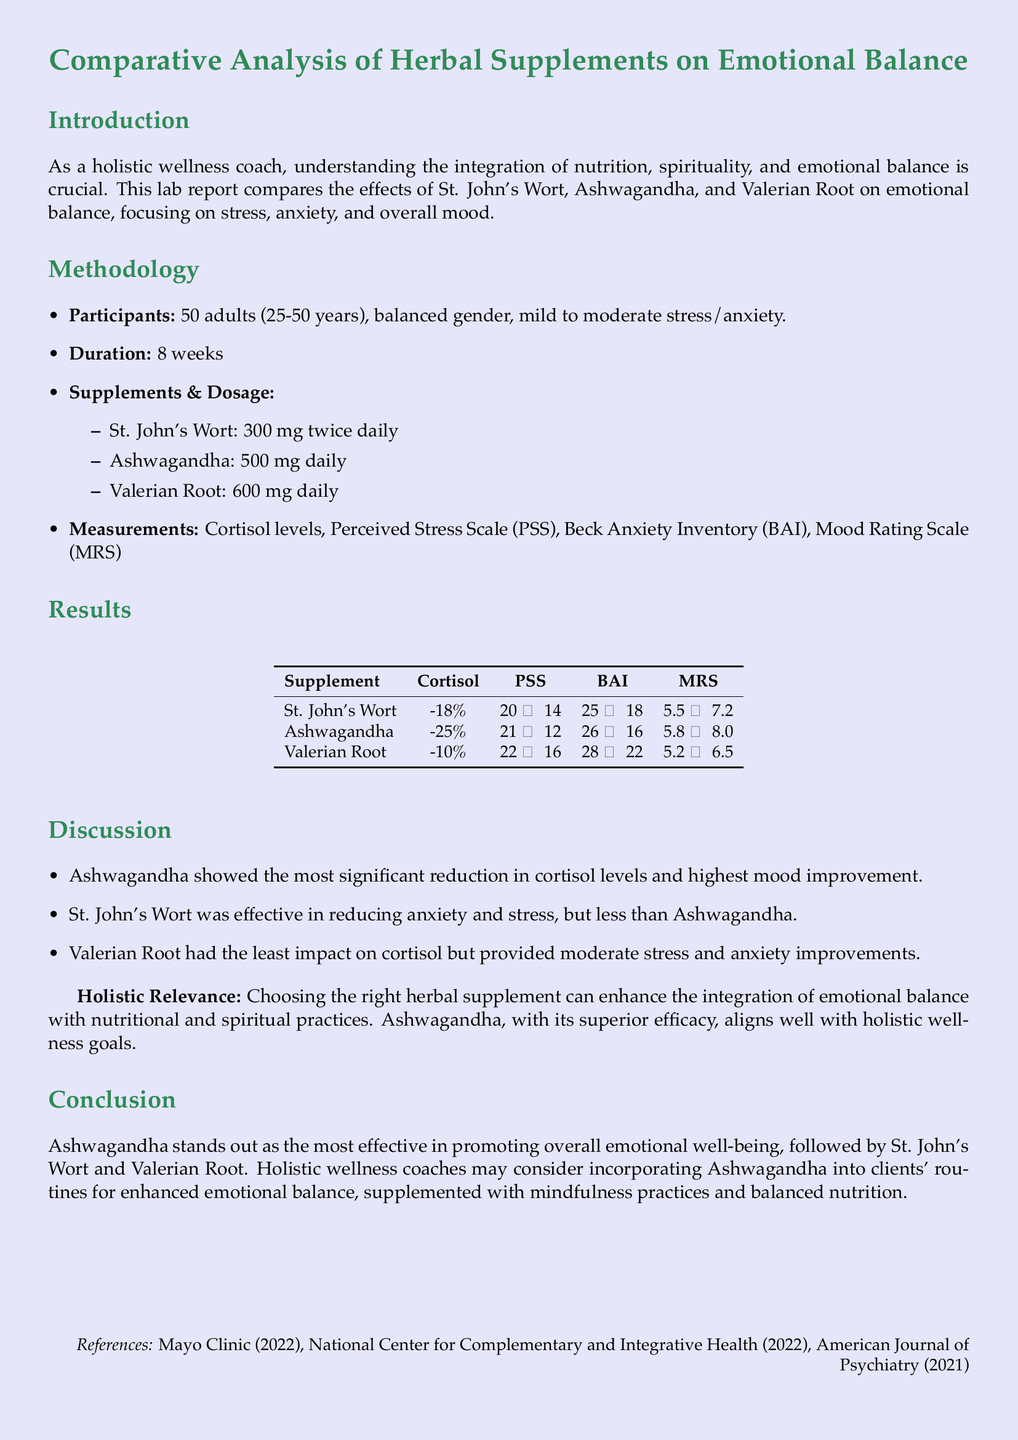What are the three herbal supplements analyzed? The document lists St. John's Wort, Ashwagandha, and Valerian Root as the herbal supplements analyzed for their effects on emotional balance.
Answer: St. John's Wort, Ashwagandha, Valerian Root What dosage of Ashwagandha was administered? The document states that Ashwagandha was given at a daily dosage of 500 mg.
Answer: 500 mg daily What was the duration of the study? According to the document, the study lasted for 8 weeks.
Answer: 8 weeks Which supplement showed the highest reduction in cortisol levels? The results compare the supplements, revealing that Ashwagandha exhibited a reduction of 25% in cortisol levels, more than the other supplements.
Answer: Ashwagandha What was the change in the Perceived Stress Scale (PSS) for St. John's Wort? The table indicates that the PSS score for St. John's Wort changed from 20 to 14, showing a clear improvement.
Answer: 20 → 14 Which supplement had the least impact on cortisol? The findings indicate that Valerian Root had the least influence on cortisol levels, with a 10% reduction.
Answer: Valerian Root What is the significance of choosing the right herbal supplement? The document emphasizes that selecting the appropriate herbal supplement can enhance emotional balance integration with dietary and spiritual practices.
Answer: Enhance integration What does the conclusion suggest for holistic wellness coaches? The conclusion indicates that coaches may consider incorporating Ashwagandha into clients' routines for improved emotional balance.
Answer: Incorporate Ashwagandha What does the Beck Anxiety Inventory (BAI) score signify for Ashwagandha? The document states that the BAI score for Ashwagandha improved from 26 to 16, indicating a significant reduction in anxiety levels.
Answer: 26 → 16 